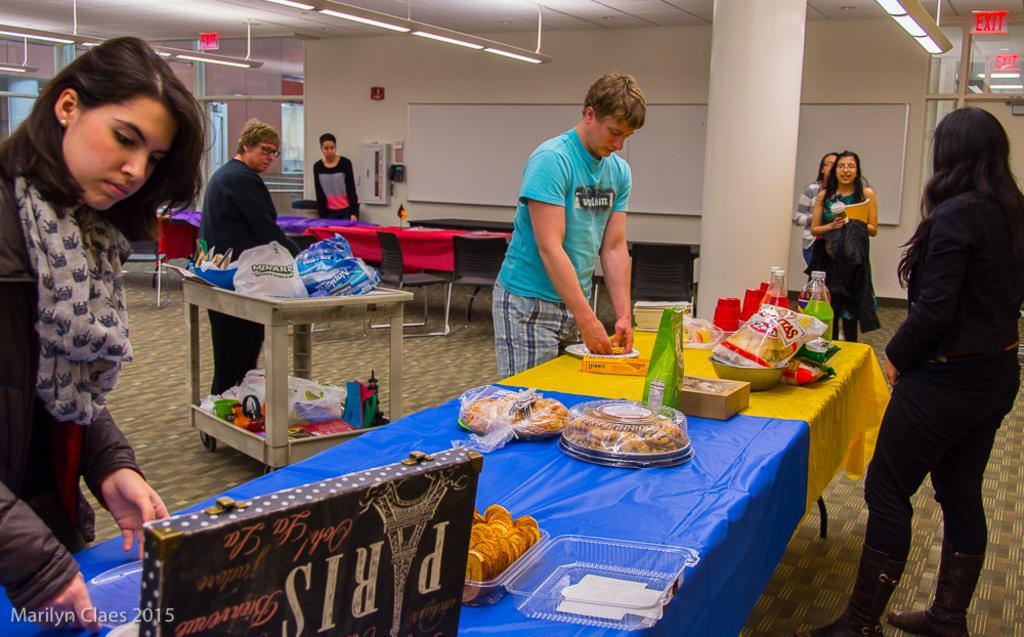Can you describe this image briefly? In the center of the image there is a table on which there are food items and other objects. In the background of the image there is a wall with white color board. There is a pillar. At the top of the image there is a ceiling with lights. There are people standing. In the center of the image there is a trolley with some objects on it. There is a woman behind it. At the bottom of the image there is a carpet. 